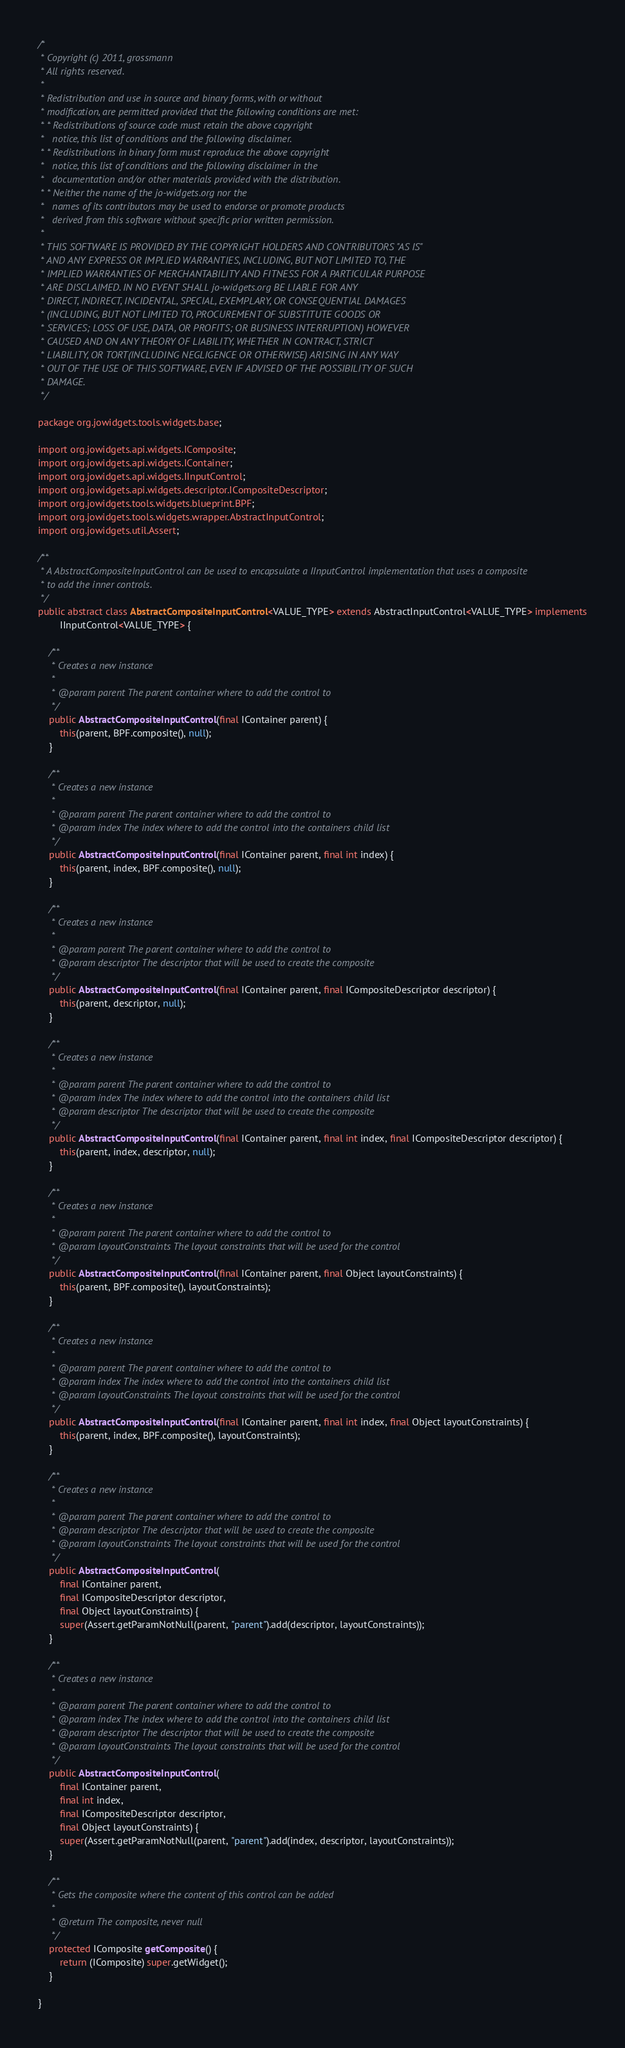Convert code to text. <code><loc_0><loc_0><loc_500><loc_500><_Java_>/*
 * Copyright (c) 2011, grossmann
 * All rights reserved.
 * 
 * Redistribution and use in source and binary forms, with or without
 * modification, are permitted provided that the following conditions are met:
 * * Redistributions of source code must retain the above copyright
 *   notice, this list of conditions and the following disclaimer.
 * * Redistributions in binary form must reproduce the above copyright
 *   notice, this list of conditions and the following disclaimer in the
 *   documentation and/or other materials provided with the distribution.
 * * Neither the name of the jo-widgets.org nor the
 *   names of its contributors may be used to endorse or promote products
 *   derived from this software without specific prior written permission.
 * 
 * THIS SOFTWARE IS PROVIDED BY THE COPYRIGHT HOLDERS AND CONTRIBUTORS "AS IS"
 * AND ANY EXPRESS OR IMPLIED WARRANTIES, INCLUDING, BUT NOT LIMITED TO, THE
 * IMPLIED WARRANTIES OF MERCHANTABILITY AND FITNESS FOR A PARTICULAR PURPOSE
 * ARE DISCLAIMED. IN NO EVENT SHALL jo-widgets.org BE LIABLE FOR ANY
 * DIRECT, INDIRECT, INCIDENTAL, SPECIAL, EXEMPLARY, OR CONSEQUENTIAL DAMAGES
 * (INCLUDING, BUT NOT LIMITED TO, PROCUREMENT OF SUBSTITUTE GOODS OR
 * SERVICES; LOSS OF USE, DATA, OR PROFITS; OR BUSINESS INTERRUPTION) HOWEVER
 * CAUSED AND ON ANY THEORY OF LIABILITY, WHETHER IN CONTRACT, STRICT
 * LIABILITY, OR TORT(INCLUDING NEGLIGENCE OR OTHERWISE) ARISING IN ANY WAY
 * OUT OF THE USE OF THIS SOFTWARE, EVEN IF ADVISED OF THE POSSIBILITY OF SUCH
 * DAMAGE.
 */

package org.jowidgets.tools.widgets.base;

import org.jowidgets.api.widgets.IComposite;
import org.jowidgets.api.widgets.IContainer;
import org.jowidgets.api.widgets.IInputControl;
import org.jowidgets.api.widgets.descriptor.ICompositeDescriptor;
import org.jowidgets.tools.widgets.blueprint.BPF;
import org.jowidgets.tools.widgets.wrapper.AbstractInputControl;
import org.jowidgets.util.Assert;

/**
 * A AbstractCompositeInputControl can be used to encapsulate a IInputControl implementation that uses a composite
 * to add the inner controls.
 */
public abstract class AbstractCompositeInputControl<VALUE_TYPE> extends AbstractInputControl<VALUE_TYPE> implements
        IInputControl<VALUE_TYPE> {

    /**
     * Creates a new instance
     * 
     * @param parent The parent container where to add the control to
     */
    public AbstractCompositeInputControl(final IContainer parent) {
        this(parent, BPF.composite(), null);
    }

    /**
     * Creates a new instance
     * 
     * @param parent The parent container where to add the control to
     * @param index The index where to add the control into the containers child list
     */
    public AbstractCompositeInputControl(final IContainer parent, final int index) {
        this(parent, index, BPF.composite(), null);
    }

    /**
     * Creates a new instance
     * 
     * @param parent The parent container where to add the control to
     * @param descriptor The descriptor that will be used to create the composite
     */
    public AbstractCompositeInputControl(final IContainer parent, final ICompositeDescriptor descriptor) {
        this(parent, descriptor, null);
    }

    /**
     * Creates a new instance
     * 
     * @param parent The parent container where to add the control to
     * @param index The index where to add the control into the containers child list
     * @param descriptor The descriptor that will be used to create the composite
     */
    public AbstractCompositeInputControl(final IContainer parent, final int index, final ICompositeDescriptor descriptor) {
        this(parent, index, descriptor, null);
    }

    /**
     * Creates a new instance
     * 
     * @param parent The parent container where to add the control to
     * @param layoutConstraints The layout constraints that will be used for the control
     */
    public AbstractCompositeInputControl(final IContainer parent, final Object layoutConstraints) {
        this(parent, BPF.composite(), layoutConstraints);
    }

    /**
     * Creates a new instance
     * 
     * @param parent The parent container where to add the control to
     * @param index The index where to add the control into the containers child list
     * @param layoutConstraints The layout constraints that will be used for the control
     */
    public AbstractCompositeInputControl(final IContainer parent, final int index, final Object layoutConstraints) {
        this(parent, index, BPF.composite(), layoutConstraints);
    }

    /**
     * Creates a new instance
     * 
     * @param parent The parent container where to add the control to
     * @param descriptor The descriptor that will be used to create the composite
     * @param layoutConstraints The layout constraints that will be used for the control
     */
    public AbstractCompositeInputControl(
        final IContainer parent,
        final ICompositeDescriptor descriptor,
        final Object layoutConstraints) {
        super(Assert.getParamNotNull(parent, "parent").add(descriptor, layoutConstraints));
    }

    /**
     * Creates a new instance
     * 
     * @param parent The parent container where to add the control to
     * @param index The index where to add the control into the containers child list
     * @param descriptor The descriptor that will be used to create the composite
     * @param layoutConstraints The layout constraints that will be used for the control
     */
    public AbstractCompositeInputControl(
        final IContainer parent,
        final int index,
        final ICompositeDescriptor descriptor,
        final Object layoutConstraints) {
        super(Assert.getParamNotNull(parent, "parent").add(index, descriptor, layoutConstraints));
    }

    /**
     * Gets the composite where the content of this control can be added
     * 
     * @return The composite, never null
     */
    protected IComposite getComposite() {
        return (IComposite) super.getWidget();
    }

}
</code> 